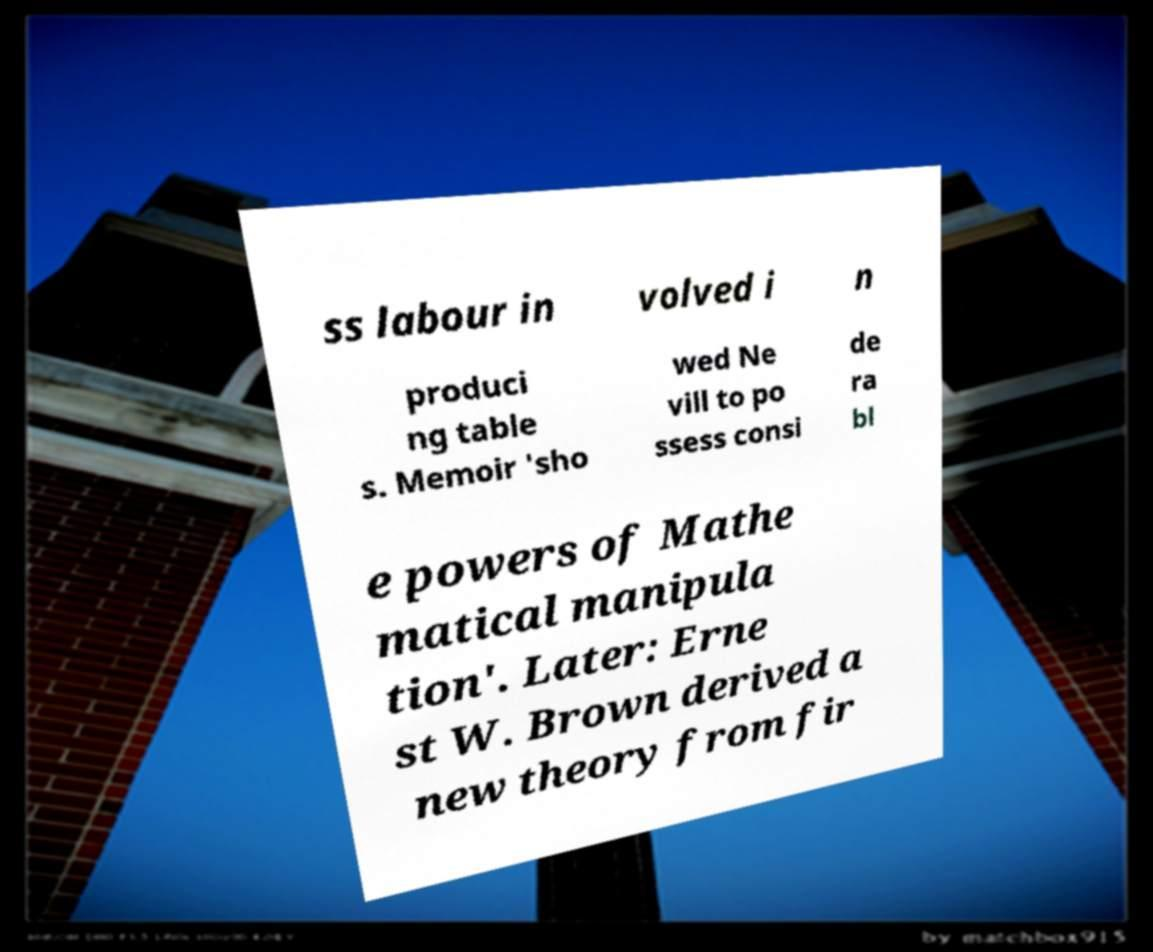There's text embedded in this image that I need extracted. Can you transcribe it verbatim? ss labour in volved i n produci ng table s. Memoir 'sho wed Ne vill to po ssess consi de ra bl e powers of Mathe matical manipula tion'. Later: Erne st W. Brown derived a new theory from fir 